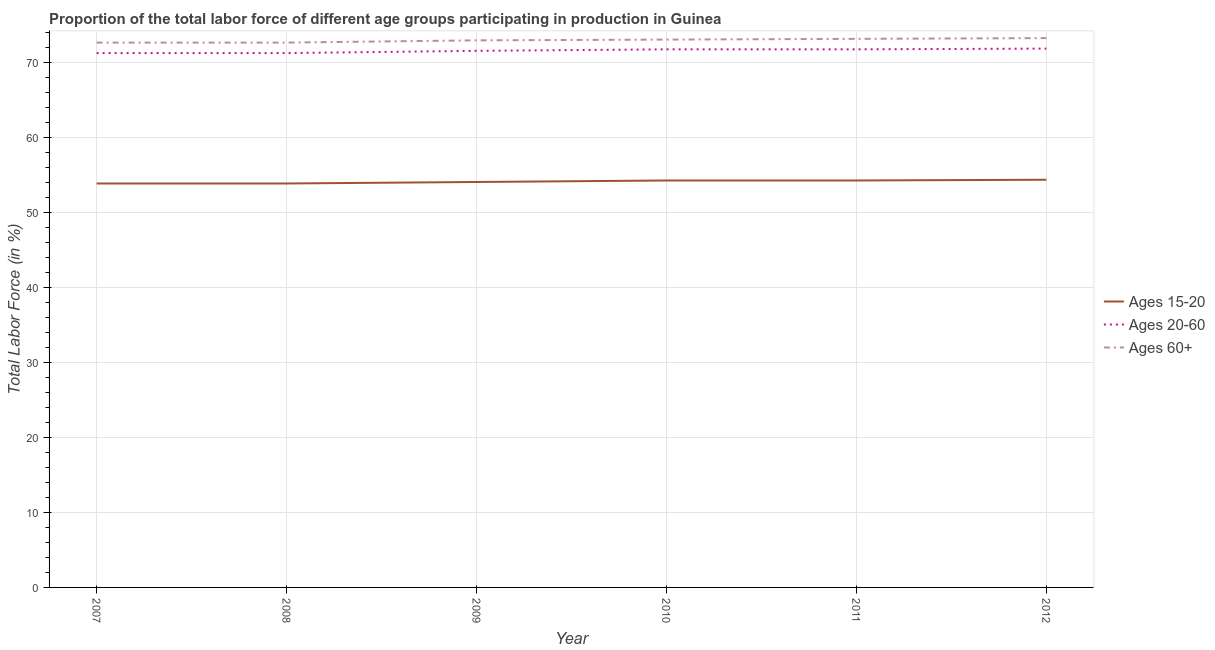How many different coloured lines are there?
Your answer should be compact. 3. Does the line corresponding to percentage of labor force within the age group 15-20 intersect with the line corresponding to percentage of labor force above age 60?
Offer a very short reply. No. Is the number of lines equal to the number of legend labels?
Provide a short and direct response. Yes. What is the percentage of labor force above age 60 in 2010?
Your response must be concise. 73.1. Across all years, what is the maximum percentage of labor force within the age group 20-60?
Make the answer very short. 71.9. Across all years, what is the minimum percentage of labor force within the age group 15-20?
Your response must be concise. 53.9. In which year was the percentage of labor force within the age group 20-60 maximum?
Ensure brevity in your answer.  2012. What is the total percentage of labor force within the age group 15-20 in the graph?
Your answer should be compact. 324.9. What is the difference between the percentage of labor force above age 60 in 2009 and that in 2012?
Ensure brevity in your answer.  -0.3. What is the difference between the percentage of labor force within the age group 15-20 in 2010 and the percentage of labor force within the age group 20-60 in 2012?
Make the answer very short. -17.6. What is the average percentage of labor force above age 60 per year?
Your answer should be very brief. 73. In the year 2007, what is the difference between the percentage of labor force above age 60 and percentage of labor force within the age group 20-60?
Offer a very short reply. 1.4. What is the ratio of the percentage of labor force within the age group 20-60 in 2008 to that in 2009?
Your response must be concise. 1. Is the percentage of labor force within the age group 15-20 in 2008 less than that in 2010?
Offer a very short reply. Yes. What is the difference between the highest and the second highest percentage of labor force within the age group 15-20?
Provide a succinct answer. 0.1. Does the percentage of labor force within the age group 20-60 monotonically increase over the years?
Offer a terse response. No. Is the percentage of labor force within the age group 20-60 strictly less than the percentage of labor force within the age group 15-20 over the years?
Provide a succinct answer. No. How many years are there in the graph?
Offer a terse response. 6. What is the difference between two consecutive major ticks on the Y-axis?
Give a very brief answer. 10. Does the graph contain any zero values?
Offer a very short reply. No. Where does the legend appear in the graph?
Give a very brief answer. Center right. What is the title of the graph?
Offer a terse response. Proportion of the total labor force of different age groups participating in production in Guinea. What is the Total Labor Force (in %) of Ages 15-20 in 2007?
Offer a very short reply. 53.9. What is the Total Labor Force (in %) in Ages 20-60 in 2007?
Ensure brevity in your answer.  71.3. What is the Total Labor Force (in %) in Ages 60+ in 2007?
Your response must be concise. 72.7. What is the Total Labor Force (in %) of Ages 15-20 in 2008?
Offer a terse response. 53.9. What is the Total Labor Force (in %) in Ages 20-60 in 2008?
Your answer should be very brief. 71.3. What is the Total Labor Force (in %) of Ages 60+ in 2008?
Make the answer very short. 72.7. What is the Total Labor Force (in %) in Ages 15-20 in 2009?
Offer a terse response. 54.1. What is the Total Labor Force (in %) in Ages 20-60 in 2009?
Your answer should be very brief. 71.6. What is the Total Labor Force (in %) in Ages 60+ in 2009?
Provide a short and direct response. 73. What is the Total Labor Force (in %) in Ages 15-20 in 2010?
Offer a terse response. 54.3. What is the Total Labor Force (in %) in Ages 20-60 in 2010?
Offer a terse response. 71.8. What is the Total Labor Force (in %) in Ages 60+ in 2010?
Ensure brevity in your answer.  73.1. What is the Total Labor Force (in %) in Ages 15-20 in 2011?
Keep it short and to the point. 54.3. What is the Total Labor Force (in %) of Ages 20-60 in 2011?
Your response must be concise. 71.8. What is the Total Labor Force (in %) of Ages 60+ in 2011?
Your answer should be very brief. 73.2. What is the Total Labor Force (in %) of Ages 15-20 in 2012?
Keep it short and to the point. 54.4. What is the Total Labor Force (in %) in Ages 20-60 in 2012?
Ensure brevity in your answer.  71.9. What is the Total Labor Force (in %) of Ages 60+ in 2012?
Give a very brief answer. 73.3. Across all years, what is the maximum Total Labor Force (in %) in Ages 15-20?
Your response must be concise. 54.4. Across all years, what is the maximum Total Labor Force (in %) in Ages 20-60?
Keep it short and to the point. 71.9. Across all years, what is the maximum Total Labor Force (in %) in Ages 60+?
Provide a succinct answer. 73.3. Across all years, what is the minimum Total Labor Force (in %) in Ages 15-20?
Offer a very short reply. 53.9. Across all years, what is the minimum Total Labor Force (in %) of Ages 20-60?
Provide a short and direct response. 71.3. Across all years, what is the minimum Total Labor Force (in %) in Ages 60+?
Provide a short and direct response. 72.7. What is the total Total Labor Force (in %) in Ages 15-20 in the graph?
Your answer should be compact. 324.9. What is the total Total Labor Force (in %) of Ages 20-60 in the graph?
Offer a very short reply. 429.7. What is the total Total Labor Force (in %) in Ages 60+ in the graph?
Provide a succinct answer. 438. What is the difference between the Total Labor Force (in %) in Ages 60+ in 2007 and that in 2008?
Make the answer very short. 0. What is the difference between the Total Labor Force (in %) of Ages 15-20 in 2007 and that in 2009?
Offer a very short reply. -0.2. What is the difference between the Total Labor Force (in %) of Ages 20-60 in 2007 and that in 2009?
Ensure brevity in your answer.  -0.3. What is the difference between the Total Labor Force (in %) of Ages 15-20 in 2007 and that in 2010?
Your answer should be very brief. -0.4. What is the difference between the Total Labor Force (in %) in Ages 20-60 in 2007 and that in 2010?
Make the answer very short. -0.5. What is the difference between the Total Labor Force (in %) in Ages 15-20 in 2007 and that in 2012?
Keep it short and to the point. -0.5. What is the difference between the Total Labor Force (in %) of Ages 20-60 in 2007 and that in 2012?
Your answer should be compact. -0.6. What is the difference between the Total Labor Force (in %) in Ages 20-60 in 2008 and that in 2009?
Offer a very short reply. -0.3. What is the difference between the Total Labor Force (in %) in Ages 15-20 in 2008 and that in 2011?
Offer a terse response. -0.4. What is the difference between the Total Labor Force (in %) in Ages 20-60 in 2008 and that in 2011?
Make the answer very short. -0.5. What is the difference between the Total Labor Force (in %) of Ages 15-20 in 2008 and that in 2012?
Your answer should be very brief. -0.5. What is the difference between the Total Labor Force (in %) of Ages 15-20 in 2009 and that in 2010?
Provide a succinct answer. -0.2. What is the difference between the Total Labor Force (in %) in Ages 60+ in 2009 and that in 2010?
Keep it short and to the point. -0.1. What is the difference between the Total Labor Force (in %) of Ages 15-20 in 2009 and that in 2011?
Give a very brief answer. -0.2. What is the difference between the Total Labor Force (in %) in Ages 20-60 in 2009 and that in 2011?
Make the answer very short. -0.2. What is the difference between the Total Labor Force (in %) in Ages 60+ in 2009 and that in 2011?
Keep it short and to the point. -0.2. What is the difference between the Total Labor Force (in %) in Ages 15-20 in 2009 and that in 2012?
Your answer should be very brief. -0.3. What is the difference between the Total Labor Force (in %) of Ages 20-60 in 2010 and that in 2011?
Ensure brevity in your answer.  0. What is the difference between the Total Labor Force (in %) of Ages 15-20 in 2011 and that in 2012?
Provide a succinct answer. -0.1. What is the difference between the Total Labor Force (in %) in Ages 20-60 in 2011 and that in 2012?
Provide a succinct answer. -0.1. What is the difference between the Total Labor Force (in %) of Ages 15-20 in 2007 and the Total Labor Force (in %) of Ages 20-60 in 2008?
Provide a succinct answer. -17.4. What is the difference between the Total Labor Force (in %) in Ages 15-20 in 2007 and the Total Labor Force (in %) in Ages 60+ in 2008?
Offer a very short reply. -18.8. What is the difference between the Total Labor Force (in %) of Ages 20-60 in 2007 and the Total Labor Force (in %) of Ages 60+ in 2008?
Your answer should be compact. -1.4. What is the difference between the Total Labor Force (in %) of Ages 15-20 in 2007 and the Total Labor Force (in %) of Ages 20-60 in 2009?
Give a very brief answer. -17.7. What is the difference between the Total Labor Force (in %) in Ages 15-20 in 2007 and the Total Labor Force (in %) in Ages 60+ in 2009?
Offer a terse response. -19.1. What is the difference between the Total Labor Force (in %) in Ages 20-60 in 2007 and the Total Labor Force (in %) in Ages 60+ in 2009?
Keep it short and to the point. -1.7. What is the difference between the Total Labor Force (in %) in Ages 15-20 in 2007 and the Total Labor Force (in %) in Ages 20-60 in 2010?
Your response must be concise. -17.9. What is the difference between the Total Labor Force (in %) of Ages 15-20 in 2007 and the Total Labor Force (in %) of Ages 60+ in 2010?
Provide a succinct answer. -19.2. What is the difference between the Total Labor Force (in %) in Ages 20-60 in 2007 and the Total Labor Force (in %) in Ages 60+ in 2010?
Your response must be concise. -1.8. What is the difference between the Total Labor Force (in %) in Ages 15-20 in 2007 and the Total Labor Force (in %) in Ages 20-60 in 2011?
Provide a succinct answer. -17.9. What is the difference between the Total Labor Force (in %) of Ages 15-20 in 2007 and the Total Labor Force (in %) of Ages 60+ in 2011?
Your response must be concise. -19.3. What is the difference between the Total Labor Force (in %) of Ages 20-60 in 2007 and the Total Labor Force (in %) of Ages 60+ in 2011?
Provide a succinct answer. -1.9. What is the difference between the Total Labor Force (in %) in Ages 15-20 in 2007 and the Total Labor Force (in %) in Ages 60+ in 2012?
Offer a terse response. -19.4. What is the difference between the Total Labor Force (in %) of Ages 20-60 in 2007 and the Total Labor Force (in %) of Ages 60+ in 2012?
Your response must be concise. -2. What is the difference between the Total Labor Force (in %) of Ages 15-20 in 2008 and the Total Labor Force (in %) of Ages 20-60 in 2009?
Offer a very short reply. -17.7. What is the difference between the Total Labor Force (in %) in Ages 15-20 in 2008 and the Total Labor Force (in %) in Ages 60+ in 2009?
Your answer should be compact. -19.1. What is the difference between the Total Labor Force (in %) of Ages 15-20 in 2008 and the Total Labor Force (in %) of Ages 20-60 in 2010?
Your response must be concise. -17.9. What is the difference between the Total Labor Force (in %) of Ages 15-20 in 2008 and the Total Labor Force (in %) of Ages 60+ in 2010?
Ensure brevity in your answer.  -19.2. What is the difference between the Total Labor Force (in %) of Ages 20-60 in 2008 and the Total Labor Force (in %) of Ages 60+ in 2010?
Keep it short and to the point. -1.8. What is the difference between the Total Labor Force (in %) of Ages 15-20 in 2008 and the Total Labor Force (in %) of Ages 20-60 in 2011?
Offer a very short reply. -17.9. What is the difference between the Total Labor Force (in %) in Ages 15-20 in 2008 and the Total Labor Force (in %) in Ages 60+ in 2011?
Your response must be concise. -19.3. What is the difference between the Total Labor Force (in %) of Ages 15-20 in 2008 and the Total Labor Force (in %) of Ages 20-60 in 2012?
Offer a very short reply. -18. What is the difference between the Total Labor Force (in %) in Ages 15-20 in 2008 and the Total Labor Force (in %) in Ages 60+ in 2012?
Your response must be concise. -19.4. What is the difference between the Total Labor Force (in %) of Ages 20-60 in 2008 and the Total Labor Force (in %) of Ages 60+ in 2012?
Provide a succinct answer. -2. What is the difference between the Total Labor Force (in %) of Ages 15-20 in 2009 and the Total Labor Force (in %) of Ages 20-60 in 2010?
Make the answer very short. -17.7. What is the difference between the Total Labor Force (in %) of Ages 20-60 in 2009 and the Total Labor Force (in %) of Ages 60+ in 2010?
Your answer should be compact. -1.5. What is the difference between the Total Labor Force (in %) in Ages 15-20 in 2009 and the Total Labor Force (in %) in Ages 20-60 in 2011?
Offer a terse response. -17.7. What is the difference between the Total Labor Force (in %) in Ages 15-20 in 2009 and the Total Labor Force (in %) in Ages 60+ in 2011?
Your response must be concise. -19.1. What is the difference between the Total Labor Force (in %) in Ages 15-20 in 2009 and the Total Labor Force (in %) in Ages 20-60 in 2012?
Make the answer very short. -17.8. What is the difference between the Total Labor Force (in %) in Ages 15-20 in 2009 and the Total Labor Force (in %) in Ages 60+ in 2012?
Ensure brevity in your answer.  -19.2. What is the difference between the Total Labor Force (in %) of Ages 15-20 in 2010 and the Total Labor Force (in %) of Ages 20-60 in 2011?
Your answer should be compact. -17.5. What is the difference between the Total Labor Force (in %) in Ages 15-20 in 2010 and the Total Labor Force (in %) in Ages 60+ in 2011?
Ensure brevity in your answer.  -18.9. What is the difference between the Total Labor Force (in %) of Ages 20-60 in 2010 and the Total Labor Force (in %) of Ages 60+ in 2011?
Keep it short and to the point. -1.4. What is the difference between the Total Labor Force (in %) in Ages 15-20 in 2010 and the Total Labor Force (in %) in Ages 20-60 in 2012?
Your response must be concise. -17.6. What is the difference between the Total Labor Force (in %) in Ages 15-20 in 2010 and the Total Labor Force (in %) in Ages 60+ in 2012?
Offer a terse response. -19. What is the difference between the Total Labor Force (in %) in Ages 20-60 in 2010 and the Total Labor Force (in %) in Ages 60+ in 2012?
Provide a short and direct response. -1.5. What is the difference between the Total Labor Force (in %) in Ages 15-20 in 2011 and the Total Labor Force (in %) in Ages 20-60 in 2012?
Your response must be concise. -17.6. What is the difference between the Total Labor Force (in %) of Ages 20-60 in 2011 and the Total Labor Force (in %) of Ages 60+ in 2012?
Your answer should be compact. -1.5. What is the average Total Labor Force (in %) in Ages 15-20 per year?
Your answer should be very brief. 54.15. What is the average Total Labor Force (in %) of Ages 20-60 per year?
Keep it short and to the point. 71.62. What is the average Total Labor Force (in %) in Ages 60+ per year?
Make the answer very short. 73. In the year 2007, what is the difference between the Total Labor Force (in %) of Ages 15-20 and Total Labor Force (in %) of Ages 20-60?
Provide a succinct answer. -17.4. In the year 2007, what is the difference between the Total Labor Force (in %) of Ages 15-20 and Total Labor Force (in %) of Ages 60+?
Your response must be concise. -18.8. In the year 2008, what is the difference between the Total Labor Force (in %) of Ages 15-20 and Total Labor Force (in %) of Ages 20-60?
Offer a very short reply. -17.4. In the year 2008, what is the difference between the Total Labor Force (in %) in Ages 15-20 and Total Labor Force (in %) in Ages 60+?
Provide a succinct answer. -18.8. In the year 2008, what is the difference between the Total Labor Force (in %) in Ages 20-60 and Total Labor Force (in %) in Ages 60+?
Offer a very short reply. -1.4. In the year 2009, what is the difference between the Total Labor Force (in %) in Ages 15-20 and Total Labor Force (in %) in Ages 20-60?
Make the answer very short. -17.5. In the year 2009, what is the difference between the Total Labor Force (in %) of Ages 15-20 and Total Labor Force (in %) of Ages 60+?
Keep it short and to the point. -18.9. In the year 2010, what is the difference between the Total Labor Force (in %) in Ages 15-20 and Total Labor Force (in %) in Ages 20-60?
Give a very brief answer. -17.5. In the year 2010, what is the difference between the Total Labor Force (in %) of Ages 15-20 and Total Labor Force (in %) of Ages 60+?
Keep it short and to the point. -18.8. In the year 2011, what is the difference between the Total Labor Force (in %) in Ages 15-20 and Total Labor Force (in %) in Ages 20-60?
Offer a terse response. -17.5. In the year 2011, what is the difference between the Total Labor Force (in %) in Ages 15-20 and Total Labor Force (in %) in Ages 60+?
Your answer should be very brief. -18.9. In the year 2012, what is the difference between the Total Labor Force (in %) in Ages 15-20 and Total Labor Force (in %) in Ages 20-60?
Offer a very short reply. -17.5. In the year 2012, what is the difference between the Total Labor Force (in %) of Ages 15-20 and Total Labor Force (in %) of Ages 60+?
Ensure brevity in your answer.  -18.9. In the year 2012, what is the difference between the Total Labor Force (in %) in Ages 20-60 and Total Labor Force (in %) in Ages 60+?
Provide a short and direct response. -1.4. What is the ratio of the Total Labor Force (in %) in Ages 15-20 in 2007 to that in 2008?
Keep it short and to the point. 1. What is the ratio of the Total Labor Force (in %) of Ages 20-60 in 2007 to that in 2008?
Offer a terse response. 1. What is the ratio of the Total Labor Force (in %) in Ages 60+ in 2007 to that in 2008?
Offer a very short reply. 1. What is the ratio of the Total Labor Force (in %) of Ages 60+ in 2007 to that in 2009?
Offer a very short reply. 1. What is the ratio of the Total Labor Force (in %) in Ages 15-20 in 2007 to that in 2010?
Your answer should be compact. 0.99. What is the ratio of the Total Labor Force (in %) in Ages 20-60 in 2007 to that in 2010?
Offer a very short reply. 0.99. What is the ratio of the Total Labor Force (in %) of Ages 60+ in 2007 to that in 2010?
Provide a short and direct response. 0.99. What is the ratio of the Total Labor Force (in %) of Ages 15-20 in 2007 to that in 2011?
Your answer should be compact. 0.99. What is the ratio of the Total Labor Force (in %) in Ages 60+ in 2007 to that in 2011?
Keep it short and to the point. 0.99. What is the ratio of the Total Labor Force (in %) of Ages 20-60 in 2007 to that in 2012?
Offer a terse response. 0.99. What is the ratio of the Total Labor Force (in %) in Ages 15-20 in 2008 to that in 2009?
Offer a very short reply. 1. What is the ratio of the Total Labor Force (in %) in Ages 60+ in 2008 to that in 2009?
Your answer should be very brief. 1. What is the ratio of the Total Labor Force (in %) in Ages 60+ in 2008 to that in 2010?
Your response must be concise. 0.99. What is the ratio of the Total Labor Force (in %) in Ages 20-60 in 2008 to that in 2011?
Provide a succinct answer. 0.99. What is the ratio of the Total Labor Force (in %) of Ages 60+ in 2008 to that in 2011?
Your response must be concise. 0.99. What is the ratio of the Total Labor Force (in %) in Ages 15-20 in 2008 to that in 2012?
Your answer should be very brief. 0.99. What is the ratio of the Total Labor Force (in %) in Ages 15-20 in 2009 to that in 2010?
Provide a succinct answer. 1. What is the ratio of the Total Labor Force (in %) of Ages 60+ in 2009 to that in 2010?
Make the answer very short. 1. What is the ratio of the Total Labor Force (in %) in Ages 15-20 in 2010 to that in 2011?
Your answer should be compact. 1. What is the ratio of the Total Labor Force (in %) of Ages 20-60 in 2010 to that in 2011?
Ensure brevity in your answer.  1. What is the ratio of the Total Labor Force (in %) of Ages 15-20 in 2010 to that in 2012?
Keep it short and to the point. 1. What is the ratio of the Total Labor Force (in %) in Ages 20-60 in 2010 to that in 2012?
Give a very brief answer. 1. What is the ratio of the Total Labor Force (in %) of Ages 60+ in 2010 to that in 2012?
Offer a very short reply. 1. What is the ratio of the Total Labor Force (in %) of Ages 15-20 in 2011 to that in 2012?
Ensure brevity in your answer.  1. What is the ratio of the Total Labor Force (in %) of Ages 20-60 in 2011 to that in 2012?
Provide a short and direct response. 1. What is the ratio of the Total Labor Force (in %) of Ages 60+ in 2011 to that in 2012?
Keep it short and to the point. 1. What is the difference between the highest and the second highest Total Labor Force (in %) of Ages 20-60?
Make the answer very short. 0.1. What is the difference between the highest and the lowest Total Labor Force (in %) of Ages 20-60?
Ensure brevity in your answer.  0.6. 